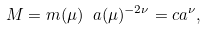Convert formula to latex. <formula><loc_0><loc_0><loc_500><loc_500>M = m ( \mu ) \ a ( \mu ) ^ { - 2 \nu } = c \L a ^ { \nu } ,</formula> 